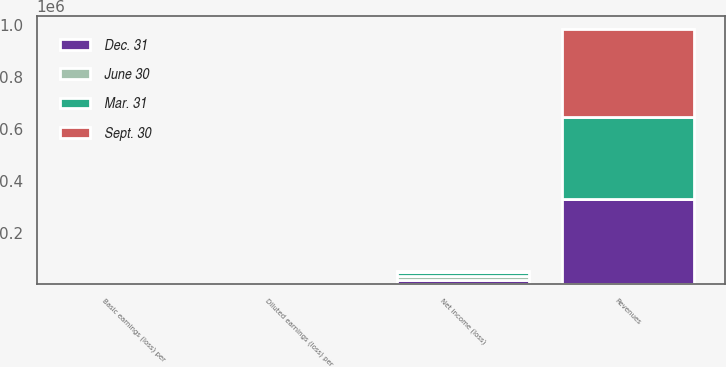Convert chart to OTSL. <chart><loc_0><loc_0><loc_500><loc_500><stacked_bar_chart><ecel><fcel>Revenues<fcel>Net income (loss)<fcel>Basic earnings (loss) per<fcel>Diluted earnings (loss) per<nl><fcel>Mar. 31<fcel>317650<fcel>15098<fcel>0.26<fcel>0.26<nl><fcel>Dec. 31<fcel>330292<fcel>17119<fcel>0.3<fcel>0.3<nl><fcel>Sept. 30<fcel>339666<fcel>1190<fcel>0.02<fcel>0.02<nl><fcel>June 30<fcel>0.3<fcel>16821<fcel>0.29<fcel>0.29<nl></chart> 